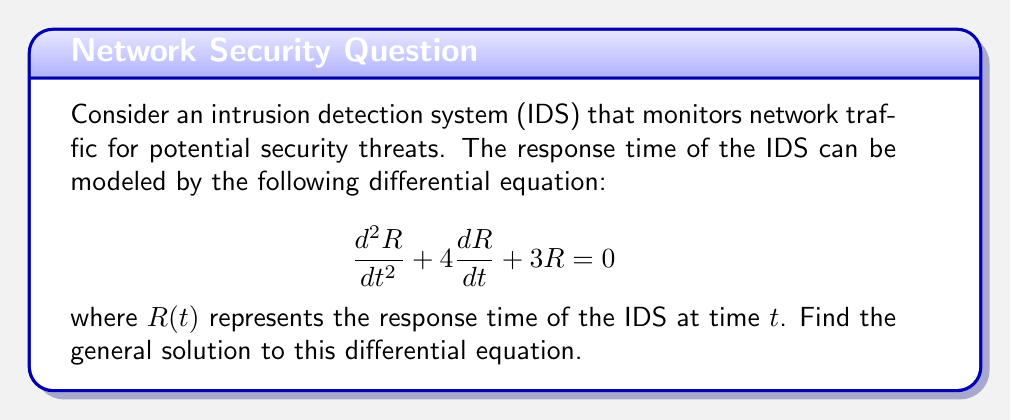Can you solve this math problem? To solve this second-order linear homogeneous differential equation, we'll follow these steps:

1) First, we need to find the characteristic equation. For a differential equation in the form:

   $$a\frac{d^2R}{dt^2} + b\frac{dR}{dt} + cR = 0$$

   The characteristic equation is:

   $$ar^2 + br + c = 0$$

2) In our case, $a=1$, $b=4$, and $c=3$. So our characteristic equation is:

   $$r^2 + 4r + 3 = 0$$

3) We can solve this quadratic equation using the quadratic formula:

   $$r = \frac{-b \pm \sqrt{b^2 - 4ac}}{2a}$$

4) Substituting our values:

   $$r = \frac{-4 \pm \sqrt{4^2 - 4(1)(3)}}{2(1)} = \frac{-4 \pm \sqrt{16 - 12}}{2} = \frac{-4 \pm \sqrt{4}}{2} = \frac{-4 \pm 2}{2}$$

5) This gives us two roots:

   $$r_1 = \frac{-4 + 2}{2} = -1$$
   $$r_2 = \frac{-4 - 2}{2} = -3$$

6) The general solution for a second-order linear homogeneous differential equation with distinct real roots is:

   $$R(t) = c_1e^{r_1t} + c_2e^{r_2t}$$

   where $c_1$ and $c_2$ are arbitrary constants.

7) Substituting our roots:

   $$R(t) = c_1e^{-t} + c_2e^{-3t}$$

This is the general solution to our differential equation.
Answer: $$R(t) = c_1e^{-t} + c_2e^{-3t}$$
where $c_1$ and $c_2$ are arbitrary constants. 